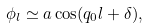<formula> <loc_0><loc_0><loc_500><loc_500>\phi _ { l } \simeq a \cos ( q _ { 0 } l + \delta ) ,</formula> 